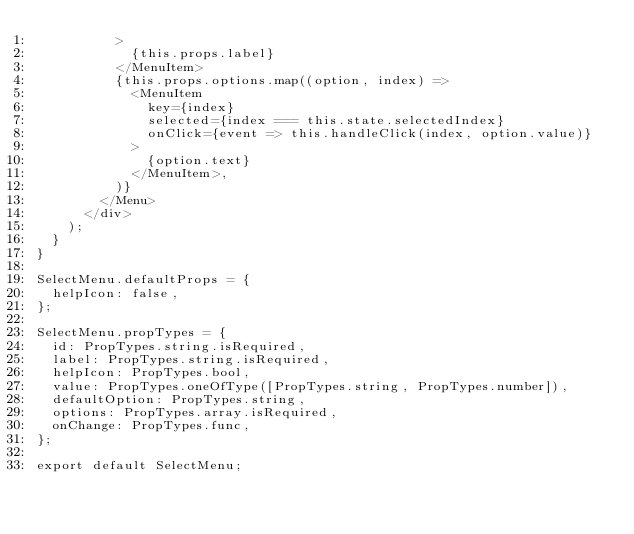Convert code to text. <code><loc_0><loc_0><loc_500><loc_500><_JavaScript_>          >
            {this.props.label}
          </MenuItem>
          {this.props.options.map((option, index) =>
            <MenuItem
              key={index}
              selected={index === this.state.selectedIndex}
              onClick={event => this.handleClick(index, option.value)}
            >
              {option.text}
            </MenuItem>,
          )}
        </Menu>
      </div>
    );
  }
}

SelectMenu.defaultProps = {
  helpIcon: false,
};

SelectMenu.propTypes = {
  id: PropTypes.string.isRequired,
  label: PropTypes.string.isRequired,
  helpIcon: PropTypes.bool,
  value: PropTypes.oneOfType([PropTypes.string, PropTypes.number]),
  defaultOption: PropTypes.string,
  options: PropTypes.array.isRequired,
  onChange: PropTypes.func,
};

export default SelectMenu;
</code> 